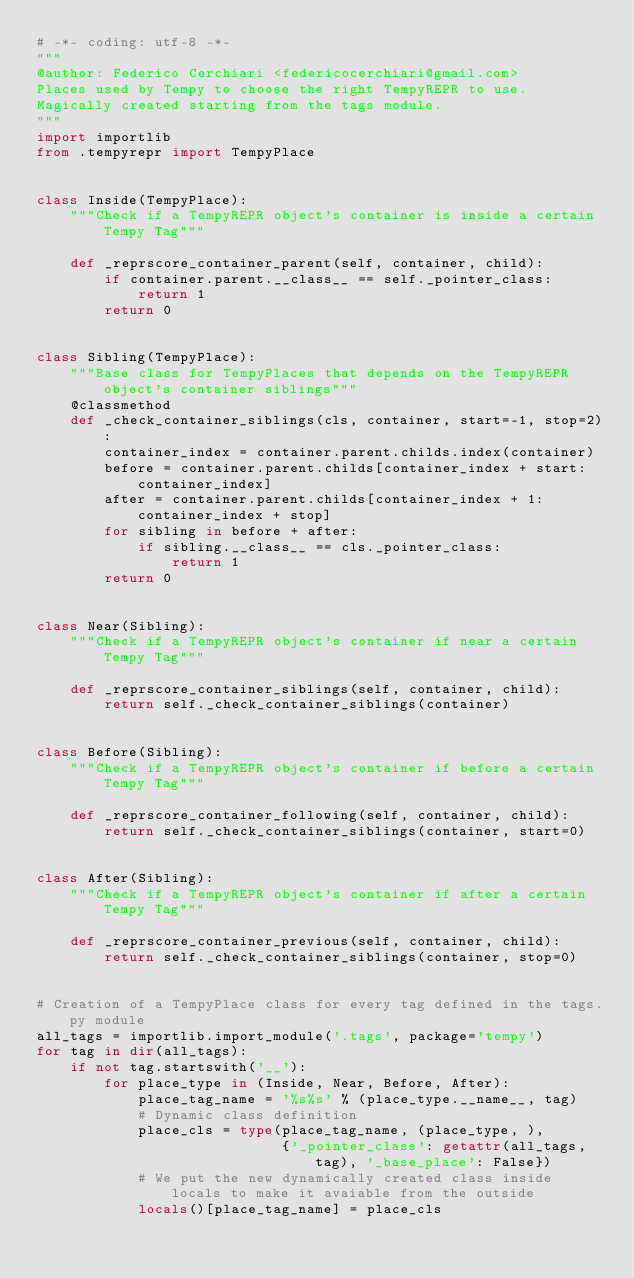Convert code to text. <code><loc_0><loc_0><loc_500><loc_500><_Python_># -*- coding: utf-8 -*-
"""
@author: Federico Cerchiari <federicocerchiari@gmail.com>
Places used by Tempy to choose the right TempyREPR to use.
Magically created starting from the tags module.
"""
import importlib
from .tempyrepr import TempyPlace


class Inside(TempyPlace):
    """Check if a TempyREPR object's container is inside a certain Tempy Tag"""

    def _reprscore_container_parent(self, container, child):
        if container.parent.__class__ == self._pointer_class:
            return 1
        return 0


class Sibling(TempyPlace):
    """Base class for TempyPlaces that depends on the TempyREPR object's container siblings"""
    @classmethod
    def _check_container_siblings(cls, container, start=-1, stop=2):
        container_index = container.parent.childs.index(container)
        before = container.parent.childs[container_index + start:container_index]
        after = container.parent.childs[container_index + 1:container_index + stop]
        for sibling in before + after:
            if sibling.__class__ == cls._pointer_class:
                return 1
        return 0


class Near(Sibling):
    """Check if a TempyREPR object's container if near a certain Tempy Tag"""

    def _reprscore_container_siblings(self, container, child):
        return self._check_container_siblings(container)


class Before(Sibling):
    """Check if a TempyREPR object's container if before a certain Tempy Tag"""

    def _reprscore_container_following(self, container, child):
        return self._check_container_siblings(container, start=0)


class After(Sibling):
    """Check if a TempyREPR object's container if after a certain Tempy Tag"""

    def _reprscore_container_previous(self, container, child):
        return self._check_container_siblings(container, stop=0)


# Creation of a TempyPlace class for every tag defined in the tags.py module
all_tags = importlib.import_module('.tags', package='tempy')
for tag in dir(all_tags):
    if not tag.startswith('__'):
        for place_type in (Inside, Near, Before, After):
            place_tag_name = '%s%s' % (place_type.__name__, tag)
            # Dynamic class definition
            place_cls = type(place_tag_name, (place_type, ),
                             {'_pointer_class': getattr(all_tags, tag), '_base_place': False})
            # We put the new dynamically created class inside locals to make it avaiable from the outside
            locals()[place_tag_name] = place_cls
</code> 